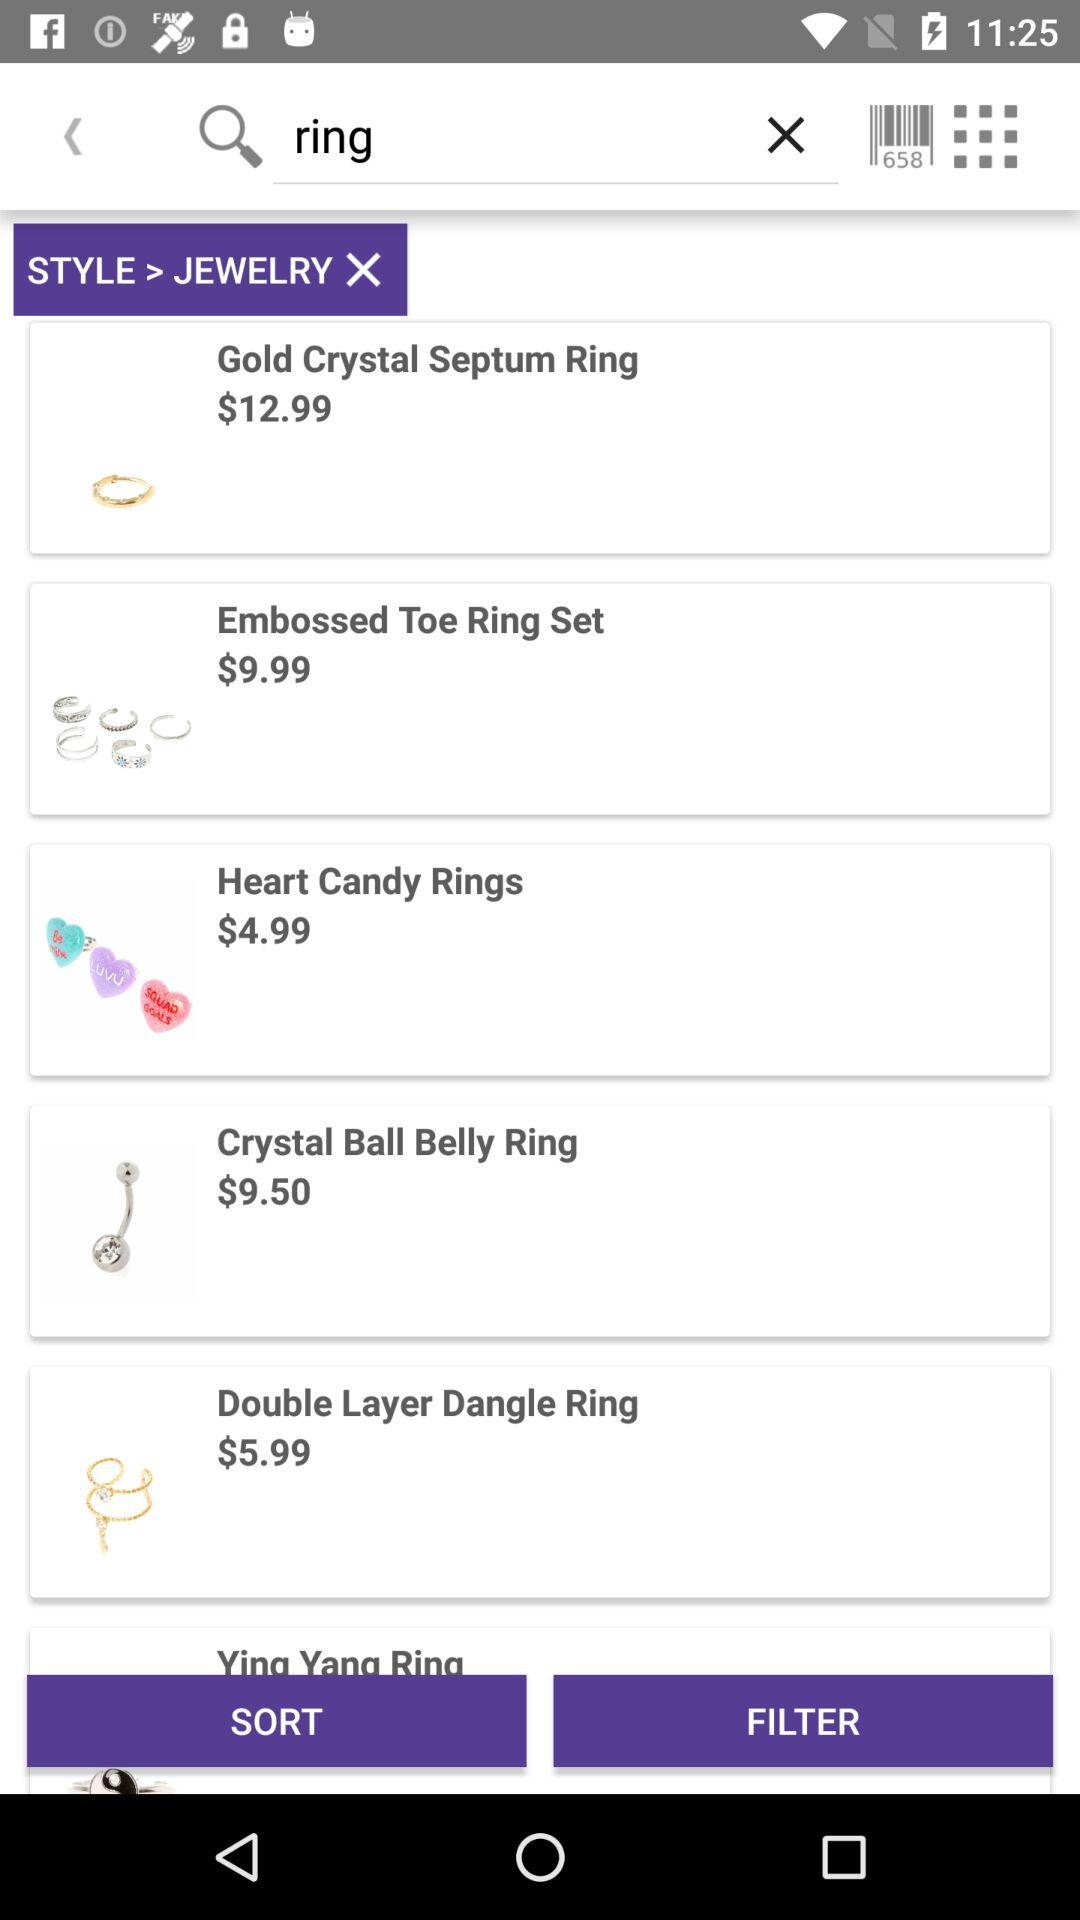How much does the necklace cost?
When the provided information is insufficient, respond with <no answer>. <no answer> 